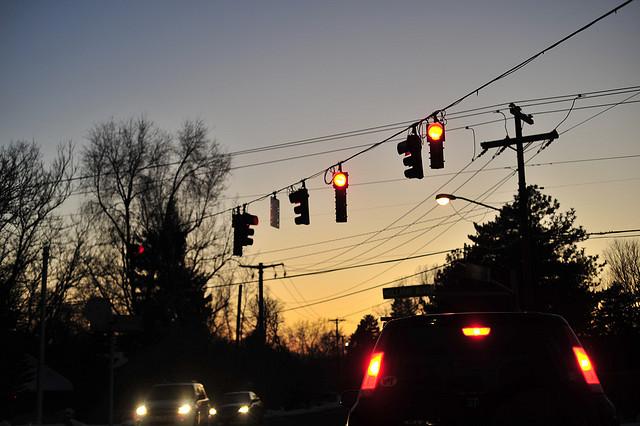What color is the parking sign?
Give a very brief answer. Red. What color is the light at?
Short answer required. Yellow. What color is the light?
Answer briefly. Red. Do cars have headlights on?
Short answer required. Yes. Is the car at a stop?
Short answer required. Yes. 